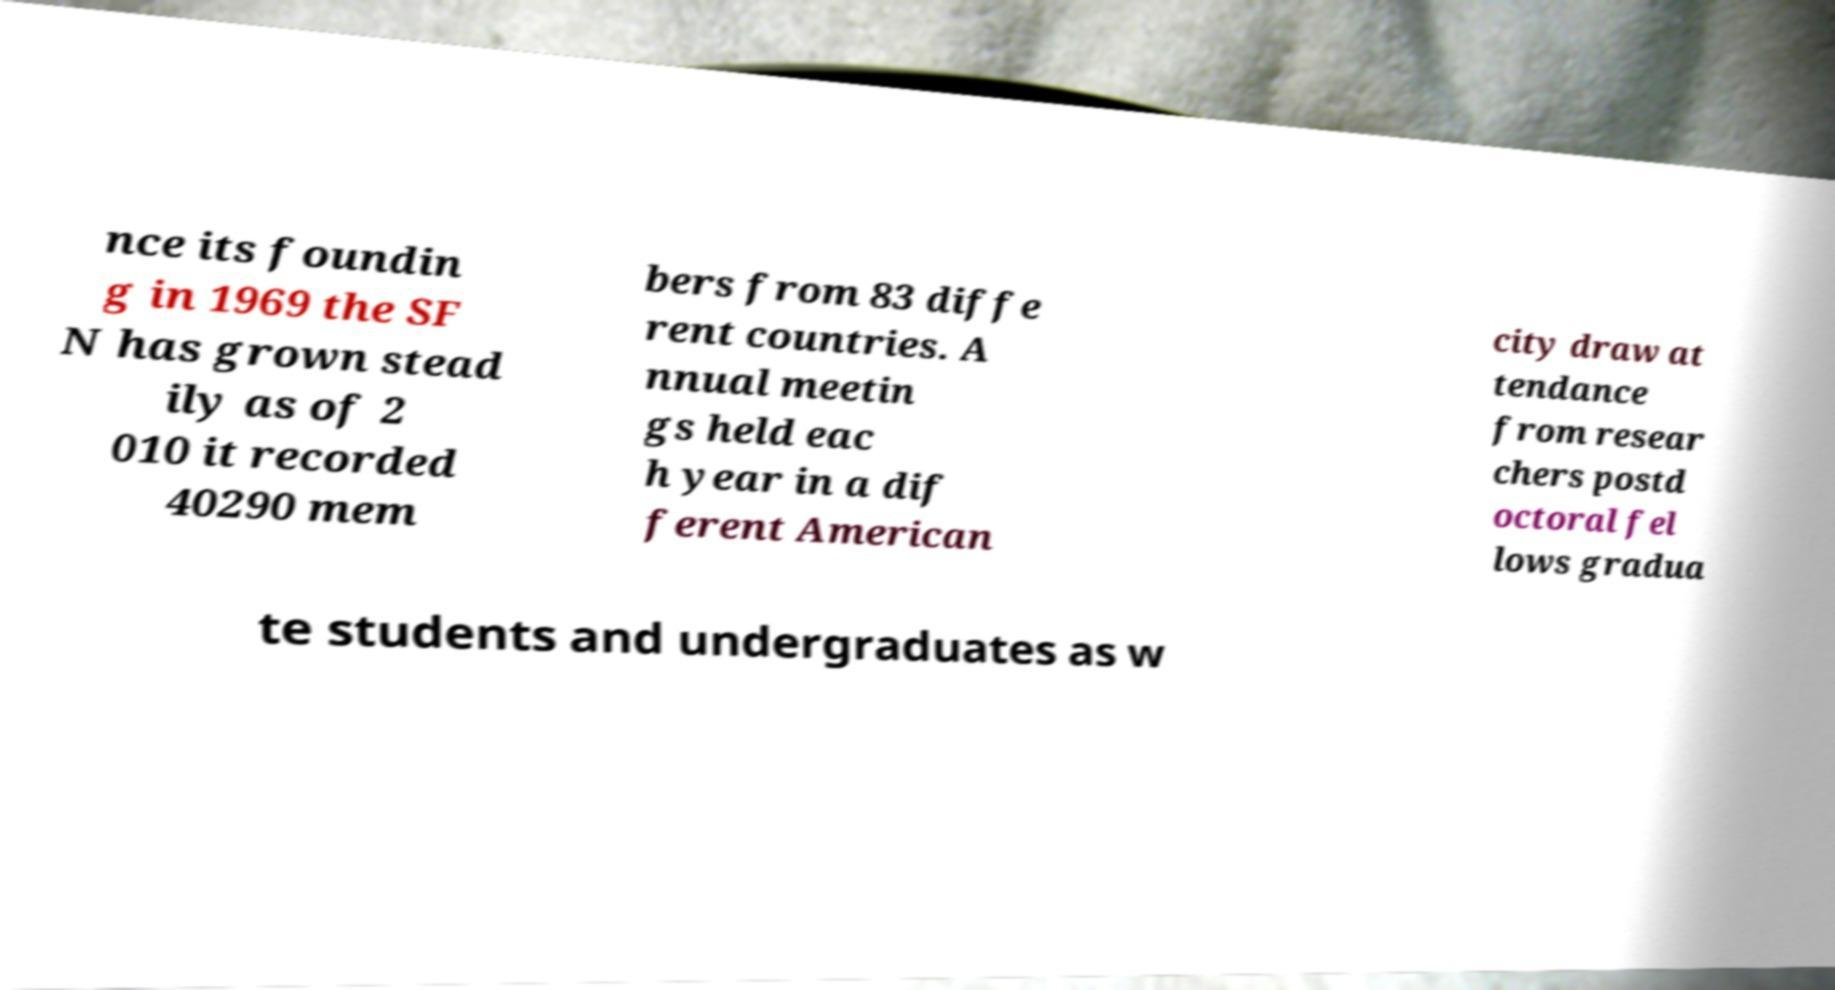For documentation purposes, I need the text within this image transcribed. Could you provide that? nce its foundin g in 1969 the SF N has grown stead ily as of 2 010 it recorded 40290 mem bers from 83 diffe rent countries. A nnual meetin gs held eac h year in a dif ferent American city draw at tendance from resear chers postd octoral fel lows gradua te students and undergraduates as w 